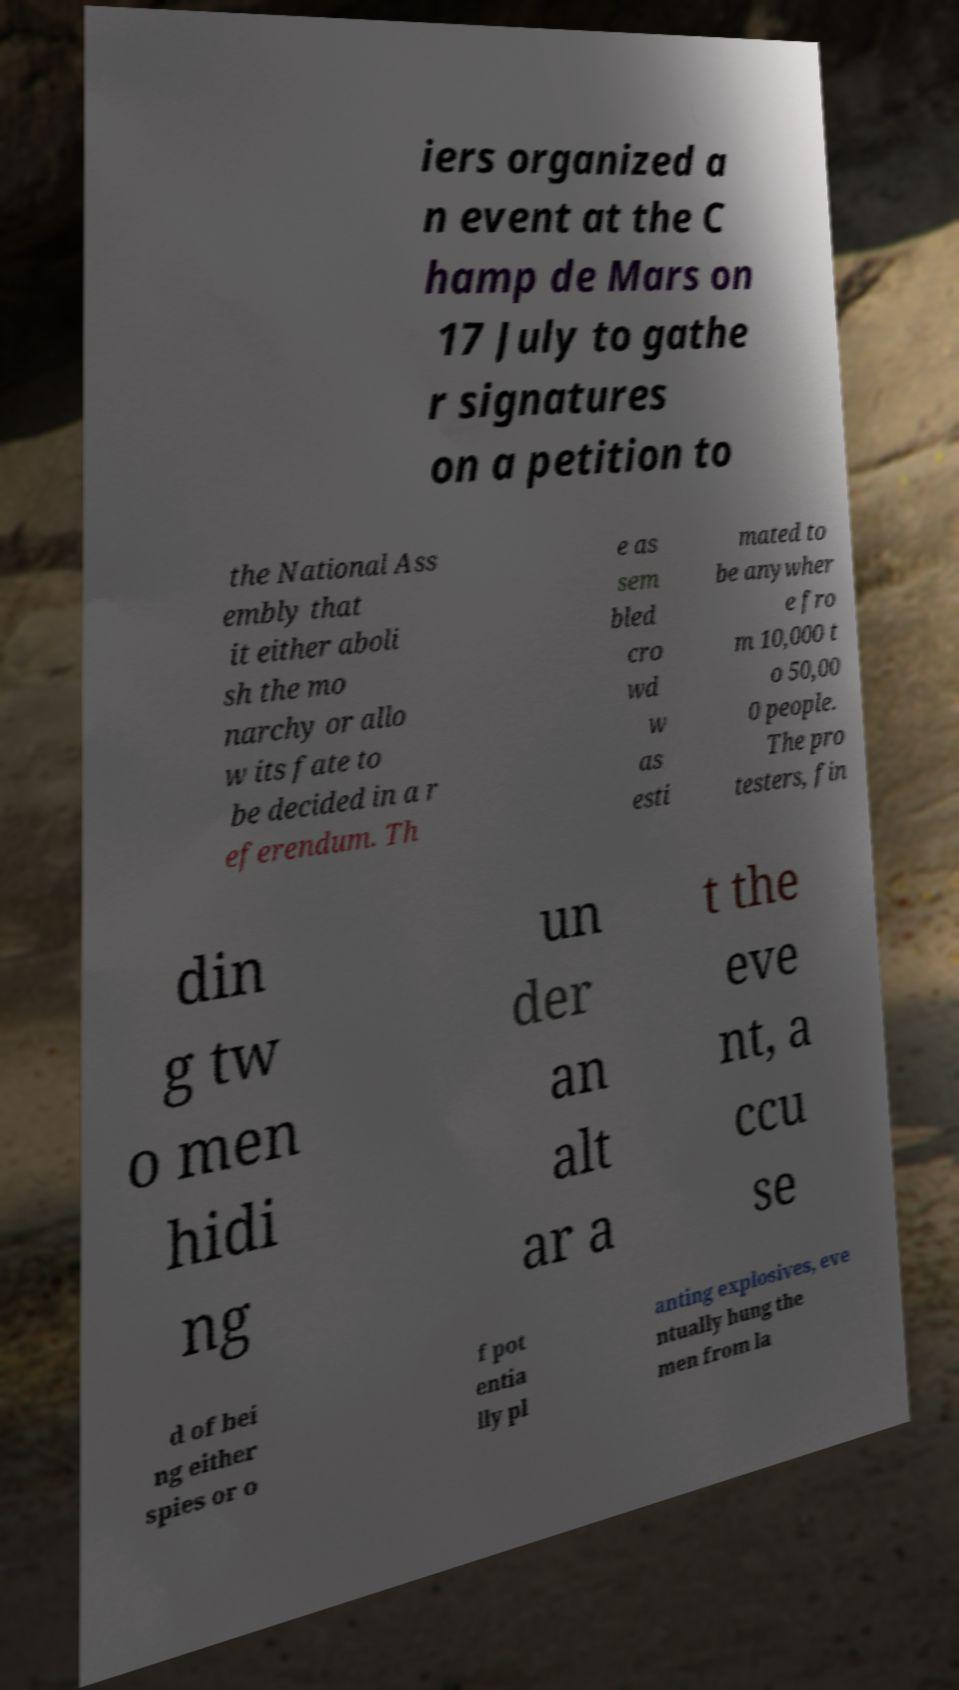Please read and relay the text visible in this image. What does it say? iers organized a n event at the C hamp de Mars on 17 July to gathe r signatures on a petition to the National Ass embly that it either aboli sh the mo narchy or allo w its fate to be decided in a r eferendum. Th e as sem bled cro wd w as esti mated to be anywher e fro m 10,000 t o 50,00 0 people. The pro testers, fin din g tw o men hidi ng un der an alt ar a t the eve nt, a ccu se d of bei ng either spies or o f pot entia lly pl anting explosives, eve ntually hung the men from la 